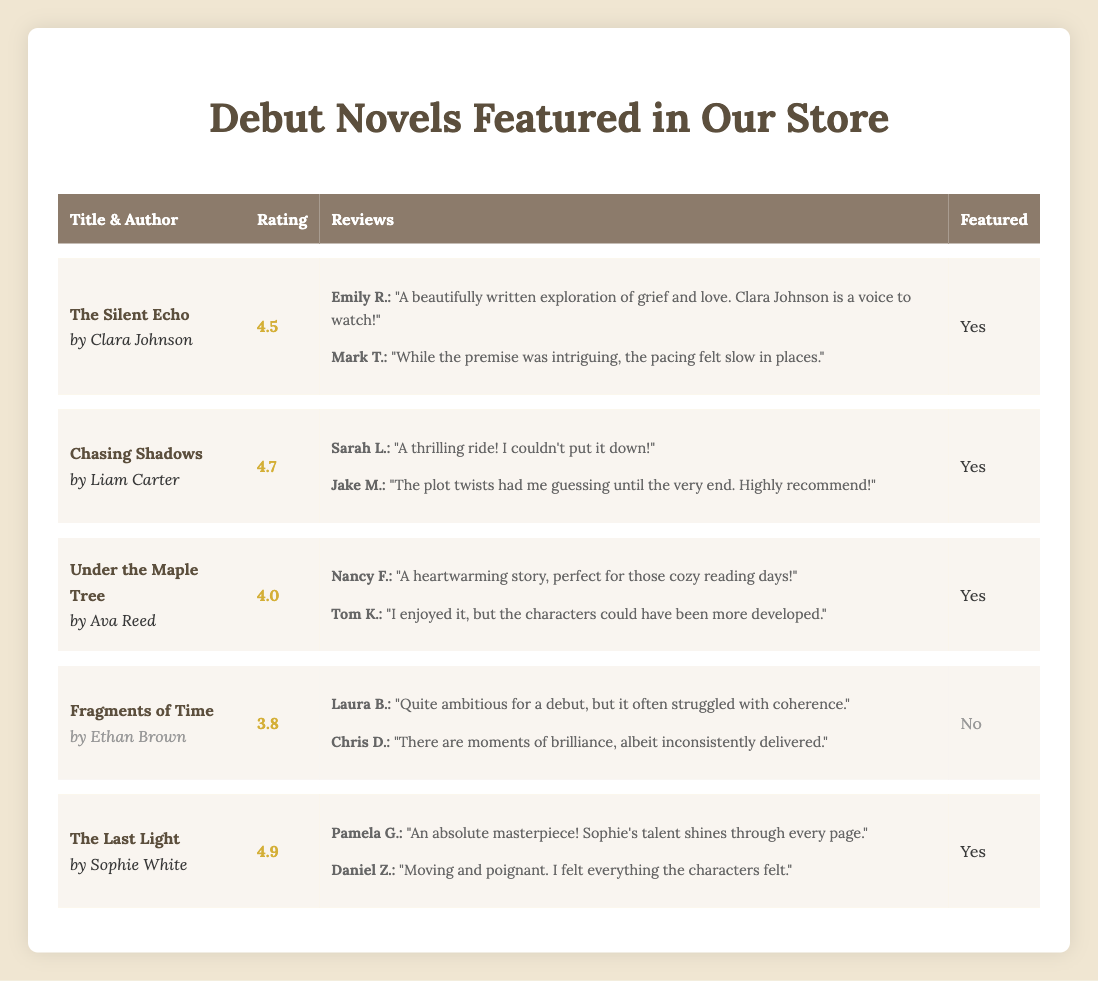What is the title of the debut novel with the highest rating? The titles and ratings are listed in the table, and I can see that "The Last Light" has a rating of 4.9, which is the highest among the debut novels featured in the store.
Answer: The Last Light How many reviews did "Under the Maple Tree" receive? The table shows that "Under the Maple Tree" has two reviews listed, one from Nancy F. and another from Tom K. Therefore, it received a total of two reviews.
Answer: 2 Is "Fragments of Time" featured in the store? Looking at the table, "Fragments of Time" is listed under the "Featured" column with a "No," which indicates that this novel is not featured in the store.
Answer: No What is the average rating of the debut novels featured in the store? The ratings of the featured novels are 4.5 (The Silent Echo), 4.7 (Chasing Shadows), 4.0 (Under the Maple Tree), and 4.9 (The Last Light). Adding these gives us 4.5 + 4.7 + 4.0 + 4.9 = 18.1. There are 4 novels, so the average rating is 18.1 / 4 = 4.525.
Answer: 4.525 Who wrote the novel with the second-highest rating? The ratings for the novels are as follows: 4.9 (The Last Light), 4.7 (Chasing Shadows), 4.5 (The Silent Echo), and 4.0 (Under the Maple Tree). The second-highest rating of 4.7 corresponds to "Chasing Shadows," which was written by Liam Carter. Therefore, Liam Carter is the author.
Answer: Liam Carter How many total reviews were provided for all the debut novels featured in the store? The total number of reviews can be calculated by counting the reviews listed for each featured novel: The Silent Echo (2), Chasing Shadows (2), Under the Maple Tree (2), and The Last Light (2), resulting in a total of 2 + 2 + 2 + 2 = 8 reviews.
Answer: 8 Which reviewer praised "The Silent Echo" and what did they say? In the reviews for "The Silent Echo," Emily R. provided a glowing review saying, "A beautifully written exploration of grief and love. Clara Johnson is a voice to watch!" This information is available in the table.
Answer: Emily R. praised it for its beautiful writing Did any novel receive a rating lower than 4? Examining the ratings of all the featured novels, "Under the Maple Tree" has a rating of 4.0, which is not below 4, but "Fragments of Time," while not featured, has a rating of 3.8, which is indeed lower than 4. Therefore, there exists a novel with a rating below 4.
Answer: Yes What is the content of the last review for "Chasing Shadows"? The last review listed for "Chasing Shadows" is from Jake M., stating, "The plot twists had me guessing until the very end. Highly recommend!" This is referenced in the table under the reviews for that novel.
Answer: "The plot twists had me guessing until the very end. Highly recommend!" 